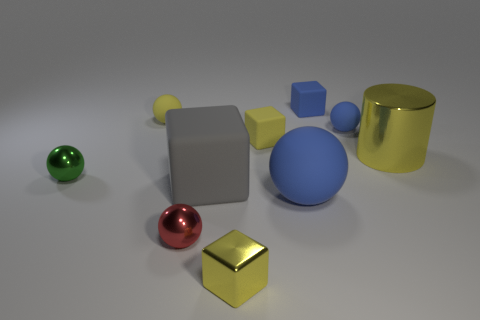There is a rubber object that is in front of the gray block; is its size the same as the tiny yellow matte block?
Make the answer very short. No. What number of tiny spheres are behind the metallic ball to the right of the small metallic object to the left of the red object?
Your answer should be very brief. 3. How many green things are large cylinders or large blocks?
Make the answer very short. 0. The small cube that is the same material as the large cylinder is what color?
Keep it short and to the point. Yellow. Is there any other thing that is the same size as the red ball?
Ensure brevity in your answer.  Yes. How many tiny objects are either metallic objects or purple cylinders?
Make the answer very short. 3. Is the number of green matte things less than the number of red things?
Your response must be concise. Yes. What color is the big object that is the same shape as the small yellow shiny object?
Keep it short and to the point. Gray. Are there any other things that are the same shape as the tiny red object?
Keep it short and to the point. Yes. Are there more big brown shiny balls than gray matte objects?
Provide a short and direct response. No. 